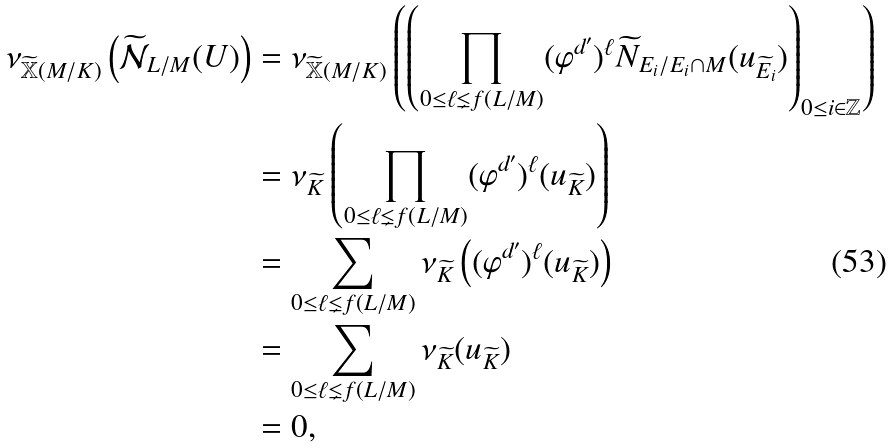<formula> <loc_0><loc_0><loc_500><loc_500>\nu _ { \widetilde { \mathbb { X } } ( M / K ) } \left ( \widetilde { \mathcal { N } } _ { L / M } ( U ) \right ) & = \nu _ { \widetilde { \mathbb { X } } ( M / K ) } \left ( \left ( \prod _ { 0 \leq \ell \lneq f ( L / M ) } ( \varphi ^ { d ^ { \prime } } ) ^ { \ell } \widetilde { N } _ { E _ { i } / E _ { i } \cap M } ( u _ { \widetilde { E } _ { i } } ) \right ) _ { 0 \leq i \in \mathbb { Z } } \right ) \\ & = \nu _ { \widetilde { K } } \left ( \prod _ { 0 \leq \ell \lneq f ( L / M ) } ( \varphi ^ { d ^ { \prime } } ) ^ { \ell } ( u _ { \widetilde { K } } ) \right ) \\ & = \sum _ { 0 \leq \ell \lneq f ( L / M ) } \nu _ { \widetilde { K } } \left ( ( \varphi ^ { d ^ { \prime } } ) ^ { \ell } ( u _ { \widetilde { K } } ) \right ) \\ & = \sum _ { 0 \leq \ell \lneq f ( L / M ) } \nu _ { \widetilde { K } } ( u _ { \widetilde { K } } ) \\ & = 0 ,</formula> 